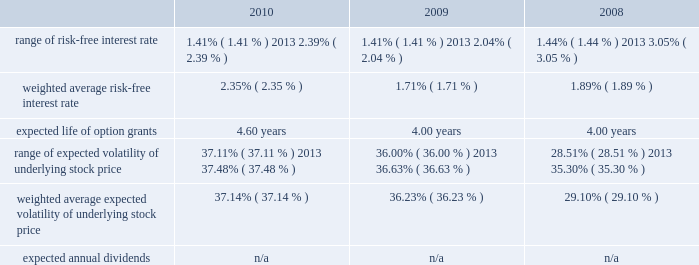American tower corporation and subsidiaries notes to consolidated financial statements assessments in each of the tax jurisdictions resulting from these examinations .
The company believes that adequate provisions have been made for income taxes for all periods through december 31 , 2010 .
12 .
Stock-based compensation the company recognized stock-based compensation of $ 52.6 million , $ 60.7 million and $ 54.8 million for the years ended december 31 , 2010 , 2009 and 2008 , respectively .
Stock-based compensation for the year ended december 31 , 2009 included $ 6.9 million related to the modification of the vesting and exercise terms for certain employee 2019s equity awards .
The company did not capitalize any stock-based compensation during the years ended december 31 , 2010 and 2009 .
Summary of stock-based compensation plans 2014the company maintains equity incentive plans that provide for the grant of stock-based awards to its directors , officers and employees .
Under the 2007 equity incentive plan ( 201c2007 plan 201d ) , which provides for the grant of non-qualified and incentive stock options , as well as restricted stock units , restricted stock and other stock-based awards , exercise prices in the case of non-qualified and incentive stock options are not less than the fair market value of the underlying common stock on the date of grant .
Equity awards typically vest ratably over various periods , generally four years , and generally expire ten years from the date of grant .
Stock options 2014as of december 31 , 2010 , the company had the ability to grant stock-based awards with respect to an aggregate of 22.0 million shares of common stock under the 2007 plan .
The fair value of each option grant is estimated on the date of grant using the black-scholes option pricing model based on the assumptions noted in the table below .
The risk-free treasury rate is based on the u.s .
Treasury yield in effect at the accounting measurement date .
The expected life ( estimated period of time outstanding ) was estimated using the vesting term and historical exercise behavior of company employees .
The expected volatility was based on historical volatility for a period equal to the expected life of the stock options .
Key assumptions used to apply this pricing model are as follows: .
The weighted average grant date fair value per share during the years ended december 31 , 2010 , 2009 and 2008 was $ 15.03 , $ 8.90 and $ 9.55 , respectively .
The intrinsic value of stock options exercised during the years ended december 31 , 2010 , 2009 and 2008 was $ 62.7 million , $ 40.1 million and $ 99.1 million , respectively .
As of december 31 , 2010 , total unrecognized compensation expense related to unvested stock options was approximately $ 27.7 million and is expected to be recognized over a weighted average period of approximately two years .
The amount of cash received from the exercise of stock options was approximately $ 129.1 million during the year ended december 31 , 2010 .
During the year ended december 31 , 2010 , the company realized approximately $ 0.3 million of state tax benefits from the exercise of stock options. .
What was the percent of the change in the weighted average risk-free interest rate? 
Computations: ((2.35 - 1.71) / 1.71)
Answer: 0.37427. 